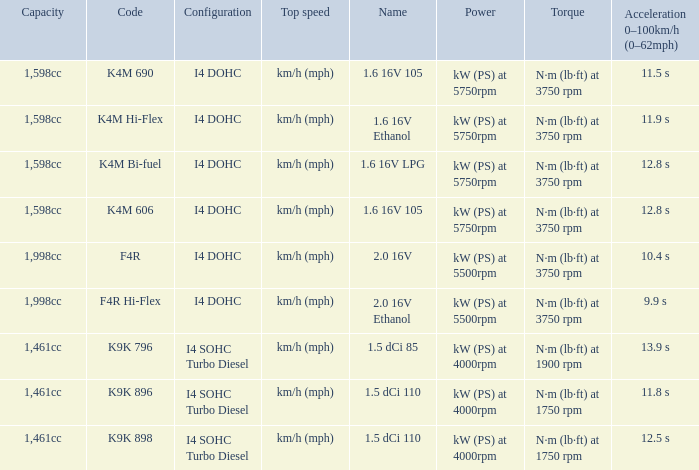What is the capacity of code f4r? 1,998cc. 